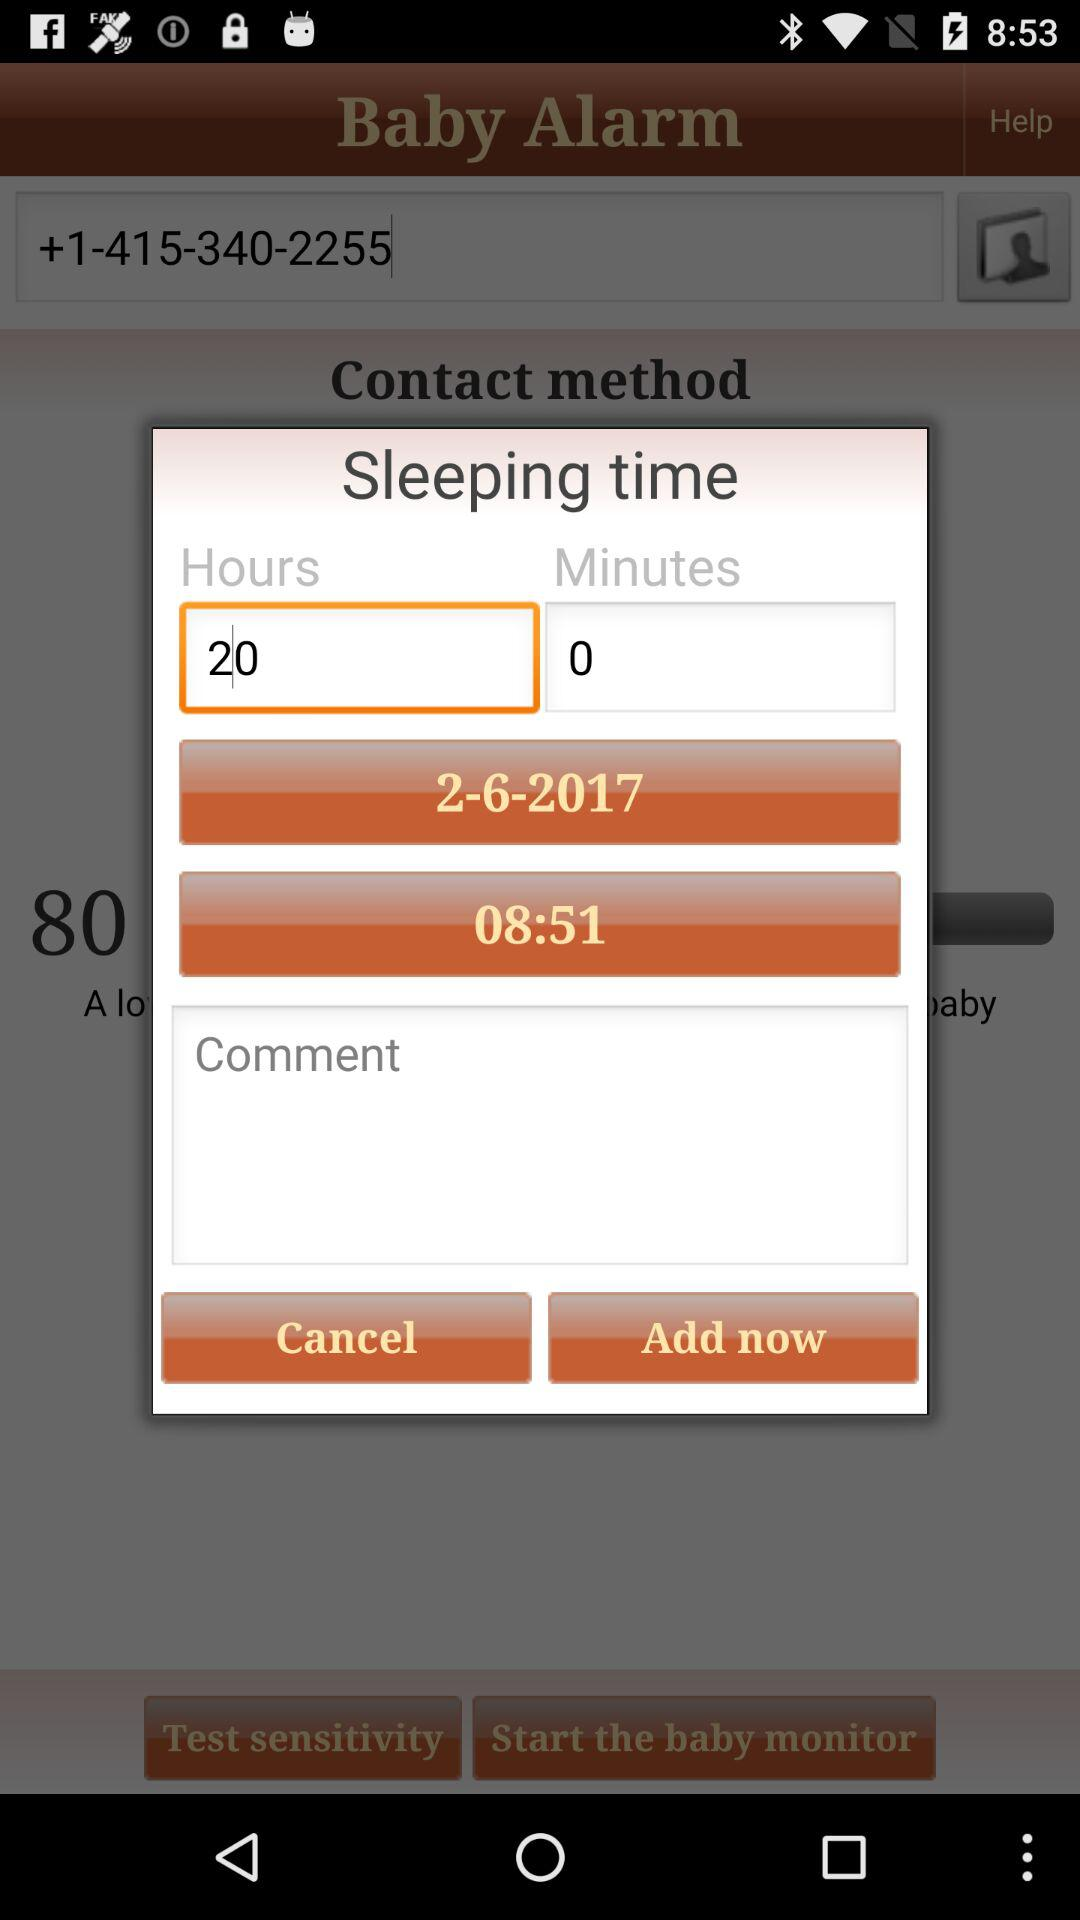What is the date of the "Sleeping time"? The date is February 6, 2017. 